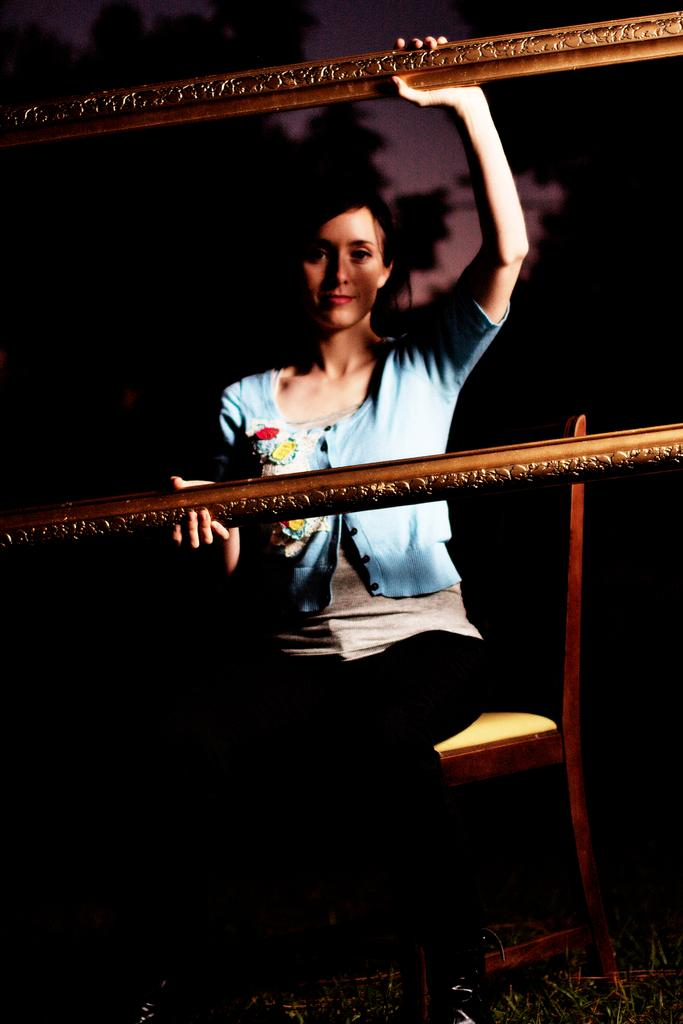Who is the main subject in the image? There is a woman in the image. What is the woman doing in the image? The woman is sitting on a chair. What is the woman holding in the image? The woman is holding an empty frame. What can be observed about the background of the image? The background of the image is dark. What type of birds can be heard singing in the image? There are no birds present in the image, so it is not possible to determine if any birds are singing. 